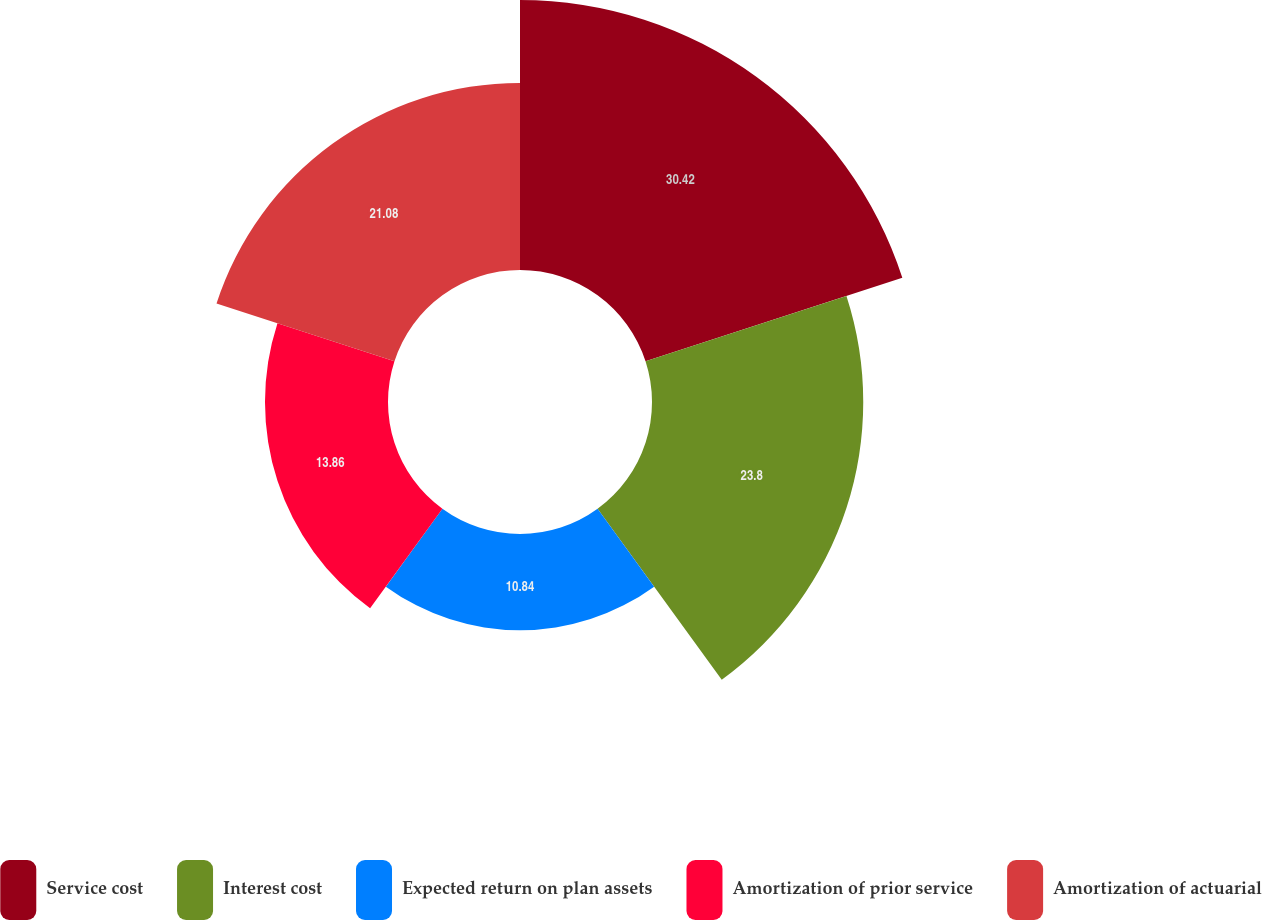Convert chart. <chart><loc_0><loc_0><loc_500><loc_500><pie_chart><fcel>Service cost<fcel>Interest cost<fcel>Expected return on plan assets<fcel>Amortization of prior service<fcel>Amortization of actuarial<nl><fcel>30.42%<fcel>23.8%<fcel>10.84%<fcel>13.86%<fcel>21.08%<nl></chart> 